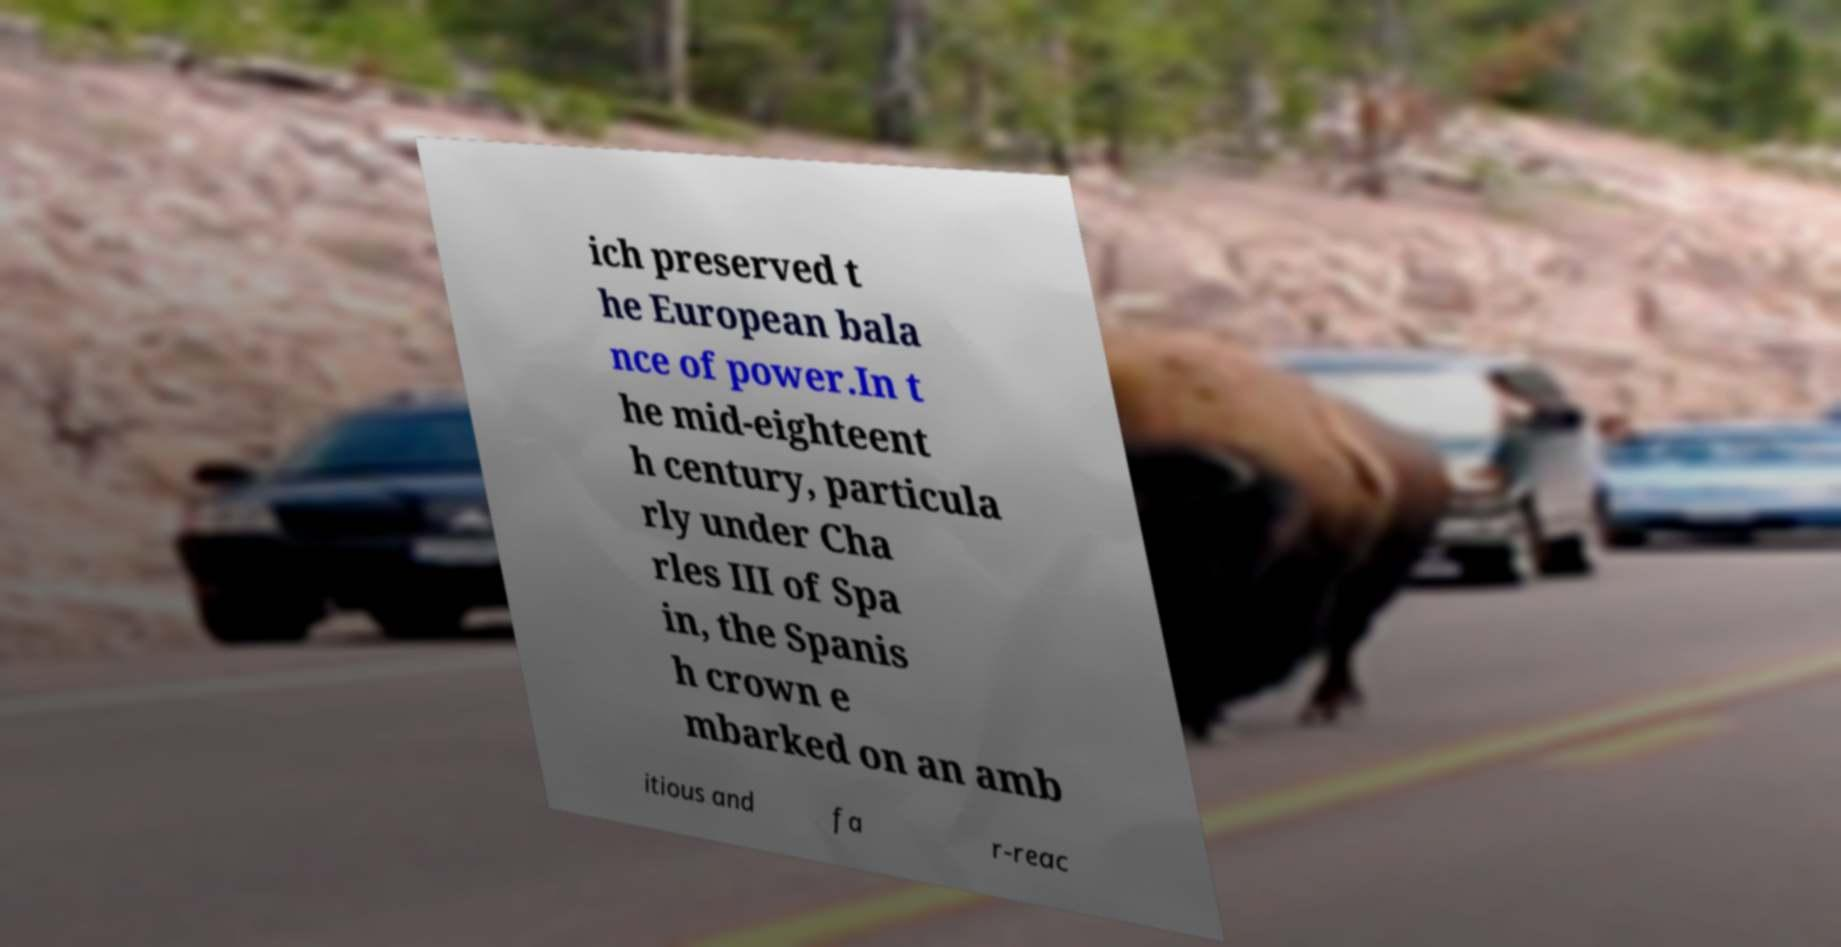There's text embedded in this image that I need extracted. Can you transcribe it verbatim? ich preserved t he European bala nce of power.In t he mid-eighteent h century, particula rly under Cha rles III of Spa in, the Spanis h crown e mbarked on an amb itious and fa r-reac 